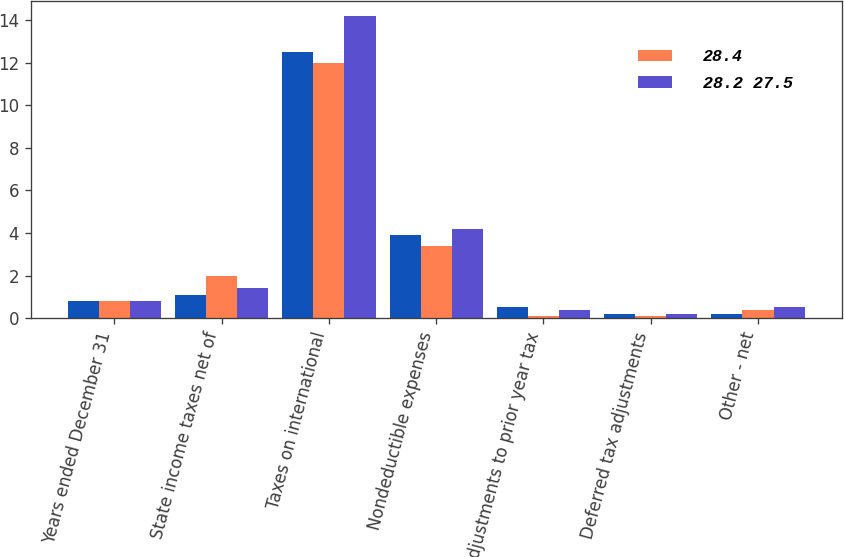Convert chart. <chart><loc_0><loc_0><loc_500><loc_500><stacked_bar_chart><ecel><fcel>Years ended December 31<fcel>State income taxes net of<fcel>Taxes on international<fcel>Nondeductible expenses<fcel>Adjustments to prior year tax<fcel>Deferred tax adjustments<fcel>Other - net<nl><fcel>nan<fcel>0.8<fcel>1.1<fcel>12.5<fcel>3.9<fcel>0.5<fcel>0.2<fcel>0.2<nl><fcel>28.4<fcel>0.8<fcel>2<fcel>12<fcel>3.4<fcel>0.1<fcel>0.1<fcel>0.4<nl><fcel>28.2 27.5<fcel>0.8<fcel>1.4<fcel>14.2<fcel>4.2<fcel>0.4<fcel>0.2<fcel>0.5<nl></chart> 